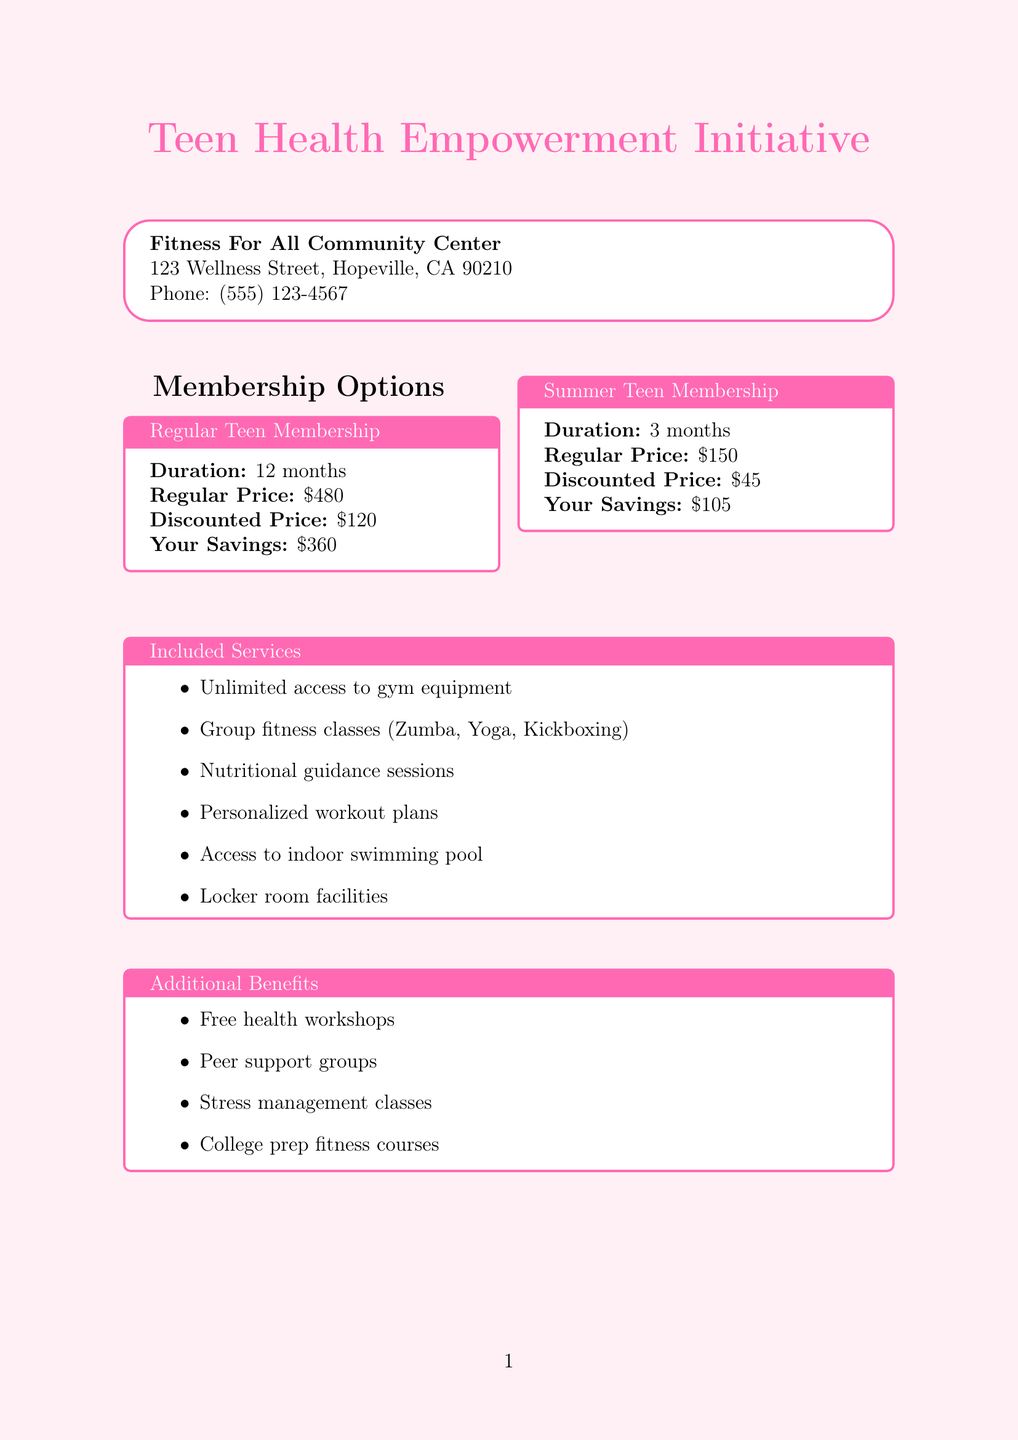What is the program name? The program name listed in the document is "Teen Health Empowerment Initiative".
Answer: Teen Health Empowerment Initiative What is the regular price for the Regular Teen Membership? The regular price for the Regular Teen Membership is stated in the membership options section.
Answer: $480 What is the duration of the Summer Teen Membership? The duration is mentioned in the details of the Summer Teen Membership.
Answer: 3 months How much can a teen save with the discounted Regular Teen Membership? The savings amount is provided in the Regular Teen Membership details.
Answer: $360 What age range must a participant fall within to be eligible? The eligibility criteria includes a specific age range for participants.
Answer: 13-19 years old What additional benefit supports teens in handling stress? One of the additional benefits listed refers to support for stress management.
Answer: Stress management classes What payment option offers an additional discount? The payment options section mentions a specific payment method that includes an additional discount.
Answer: Upfront annual payment Who is the provider of this gym membership? The document specifies the name of the fitness center providing the membership.
Answer: Fitness For All Community Center What type of workout classes are included? The included services section lists types of fitness classes available to members.
Answer: Group fitness classes (Zumba, Yoga, Kickboxing) 